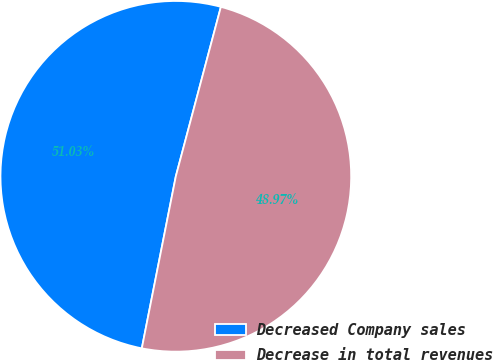Convert chart. <chart><loc_0><loc_0><loc_500><loc_500><pie_chart><fcel>Decreased Company sales<fcel>Decrease in total revenues<nl><fcel>51.03%<fcel>48.97%<nl></chart> 